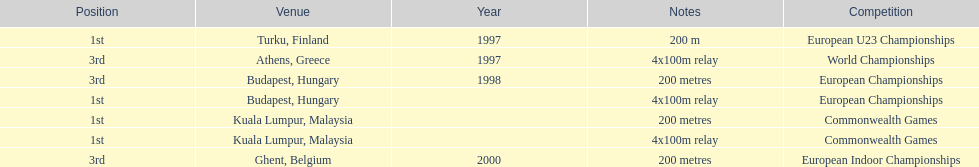Parse the full table. {'header': ['Position', 'Venue', 'Year', 'Notes', 'Competition'], 'rows': [['1st', 'Turku, Finland', '1997', '200 m', 'European U23 Championships'], ['3rd', 'Athens, Greece', '1997', '4x100m relay', 'World Championships'], ['3rd', 'Budapest, Hungary', '1998', '200 metres', 'European Championships'], ['1st', 'Budapest, Hungary', '', '4x100m relay', 'European Championships'], ['1st', 'Kuala Lumpur, Malaysia', '', '200 metres', 'Commonwealth Games'], ['1st', 'Kuala Lumpur, Malaysia', '', '4x100m relay', 'Commonwealth Games'], ['3rd', 'Ghent, Belgium', '2000', '200 metres', 'European Indoor Championships']]} How many 4x 100m relays were run? 3. 